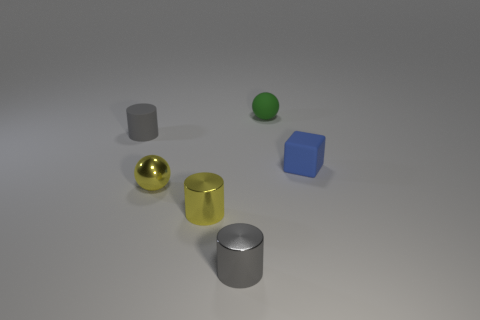What is the shape of the gray matte object?
Give a very brief answer. Cylinder. What is the color of the matte cylinder that is the same size as the green matte ball?
Provide a short and direct response. Gray. What number of gray things are tiny metallic objects or rubber cylinders?
Make the answer very short. 2. Are there more large yellow rubber balls than balls?
Offer a terse response. No. Is the size of the sphere that is behind the tiny gray rubber cylinder the same as the gray thing in front of the small yellow cylinder?
Offer a very short reply. Yes. What color is the small rubber sphere on the right side of the gray cylinder that is behind the gray thing that is in front of the tiny yellow sphere?
Provide a short and direct response. Green. Are there any large gray rubber objects of the same shape as the green thing?
Provide a succinct answer. No. Are there more small yellow shiny things that are behind the yellow metallic cylinder than tiny red matte objects?
Offer a very short reply. Yes. What number of metal objects are either tiny green spheres or balls?
Make the answer very short. 1. Are there any tiny gray matte objects that are in front of the tiny gray rubber object in front of the green matte thing?
Your response must be concise. No. 